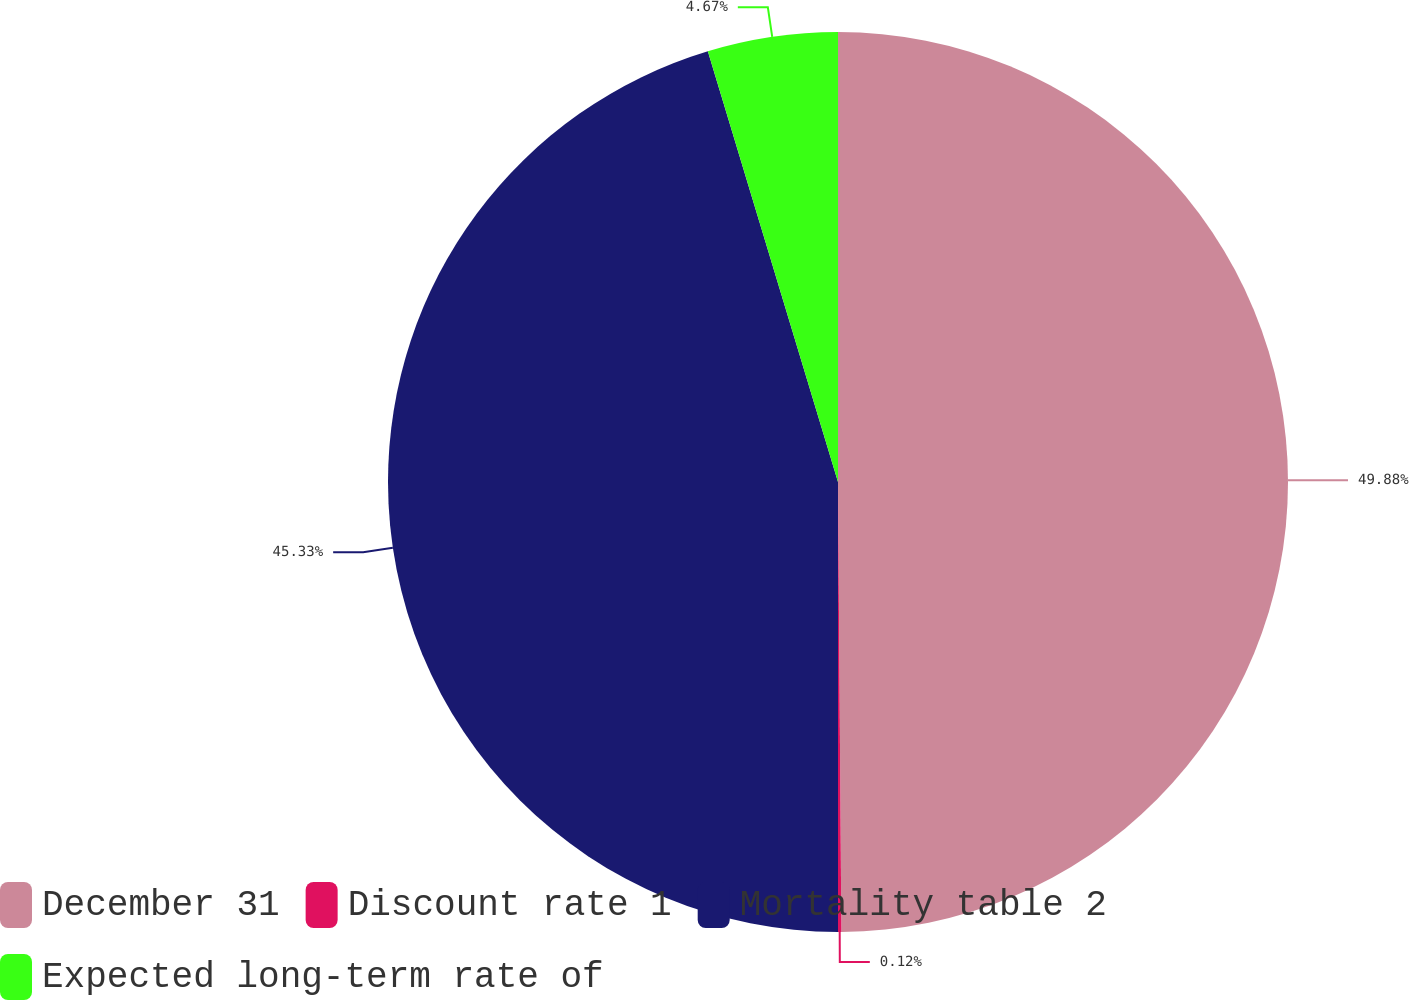Convert chart to OTSL. <chart><loc_0><loc_0><loc_500><loc_500><pie_chart><fcel>December 31<fcel>Discount rate 1<fcel>Mortality table 2<fcel>Expected long-term rate of<nl><fcel>49.88%<fcel>0.12%<fcel>45.33%<fcel>4.67%<nl></chart> 